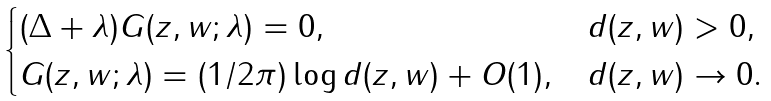<formula> <loc_0><loc_0><loc_500><loc_500>\begin{cases} ( \Delta + \lambda ) G ( z , w ; \lambda ) = 0 , & d ( z , w ) > 0 , \\ G ( z , w ; \lambda ) = ( 1 / 2 \pi ) \log d ( z , w ) + O ( 1 ) , & d ( z , w ) \to 0 . \end{cases}</formula> 